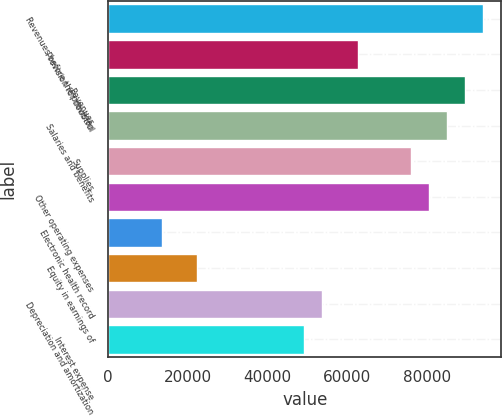Convert chart. <chart><loc_0><loc_0><loc_500><loc_500><bar_chart><fcel>Revenues before the provision<fcel>Provision for doubtful<fcel>Revenues<fcel>Salaries and benefits<fcel>Supplies<fcel>Other operating expenses<fcel>Electronic health record<fcel>Equity in earnings of<fcel>Depreciation and amortization<fcel>Interest expense<nl><fcel>93964.3<fcel>62644.2<fcel>89490<fcel>85015.7<fcel>76067.1<fcel>80541.4<fcel>13426.9<fcel>22375.5<fcel>53695.6<fcel>49221.3<nl></chart> 